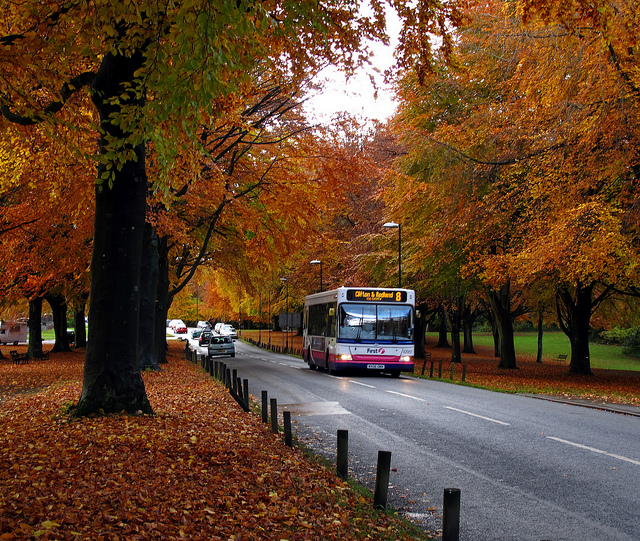Read all the text in this image. 8 